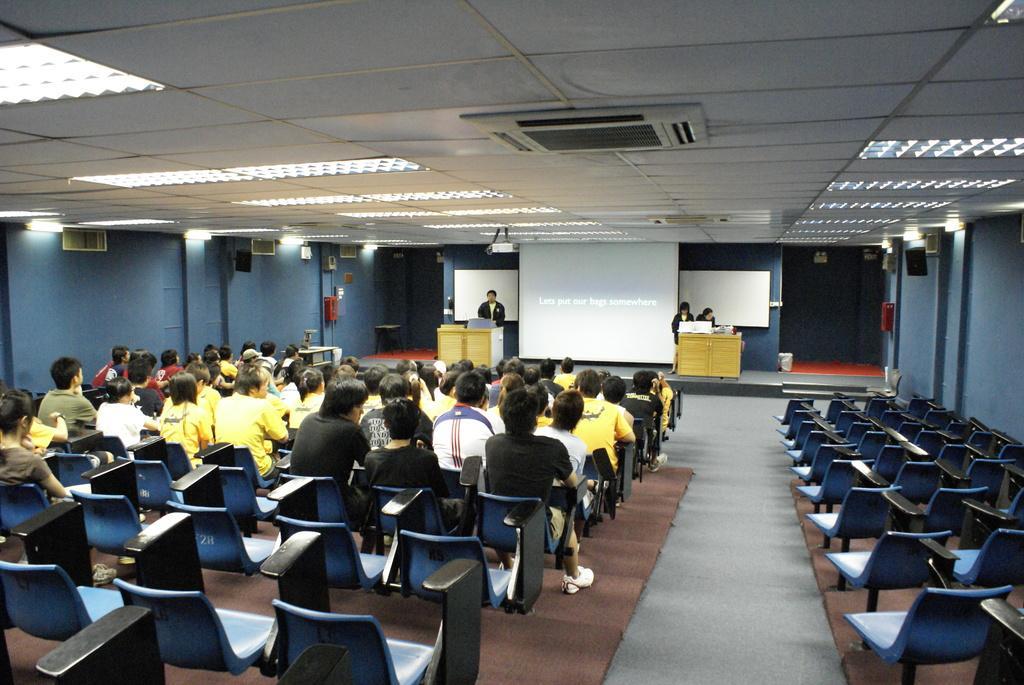Can you describe this image briefly? The image is taken in the hall. In the center of the image there is a man standing. There is a podium before him. In the center there is a screen. On the right there are chairs. On the left there are many people sitting. At the top there are lights. 